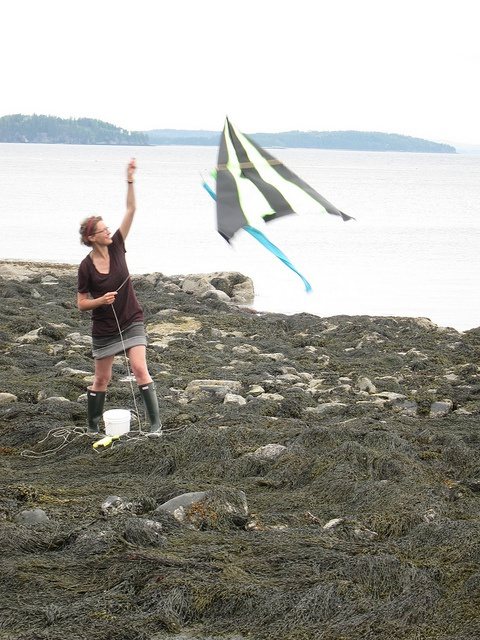Describe the objects in this image and their specific colors. I can see people in white, black, gray, and brown tones and kite in white, gray, and lightblue tones in this image. 